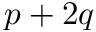<formula> <loc_0><loc_0><loc_500><loc_500>p + 2 q</formula> 